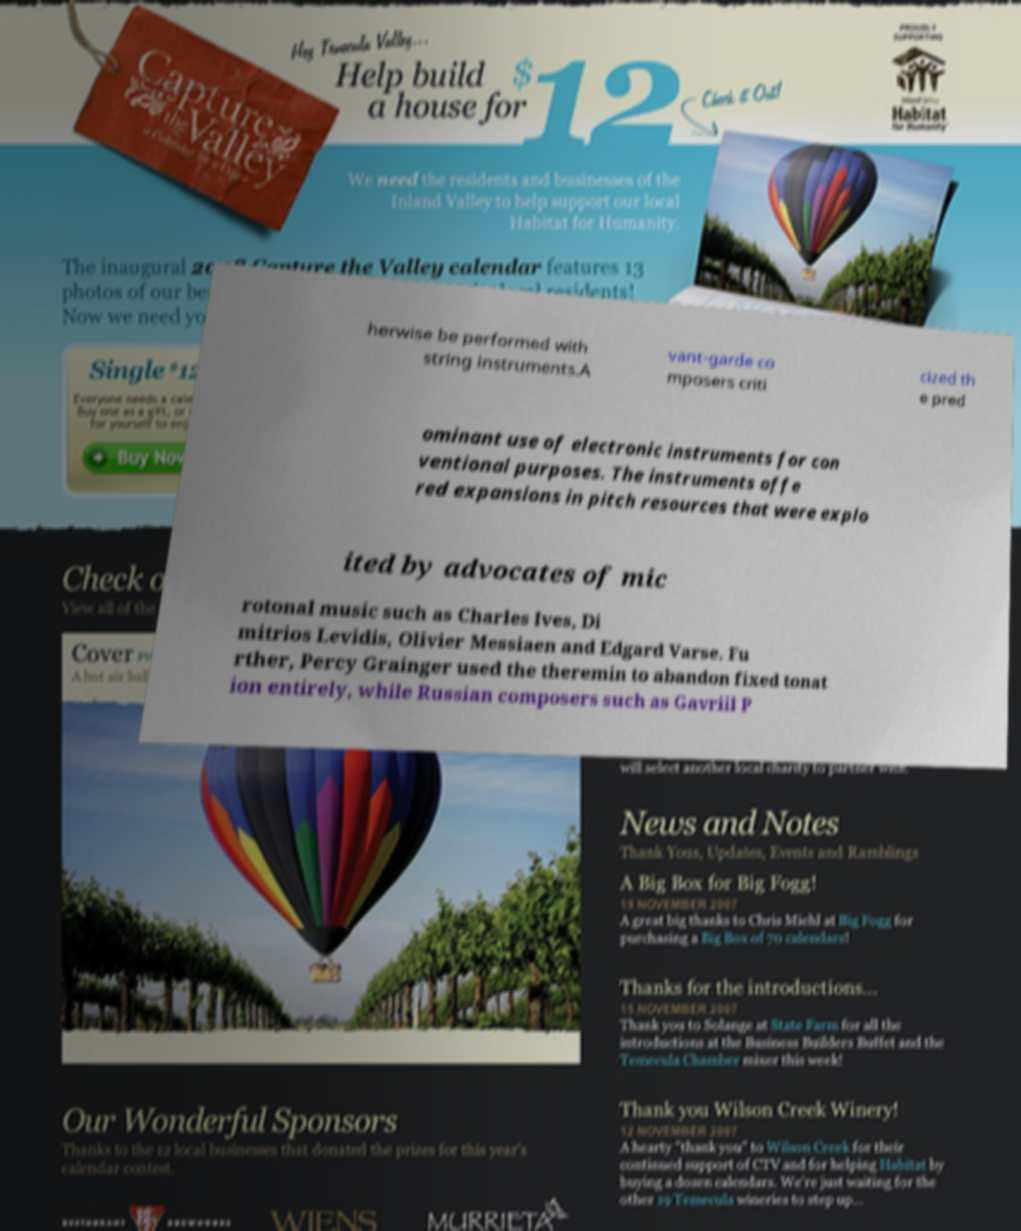I need the written content from this picture converted into text. Can you do that? herwise be performed with string instruments.A vant-garde co mposers criti cized th e pred ominant use of electronic instruments for con ventional purposes. The instruments offe red expansions in pitch resources that were explo ited by advocates of mic rotonal music such as Charles Ives, Di mitrios Levidis, Olivier Messiaen and Edgard Varse. Fu rther, Percy Grainger used the theremin to abandon fixed tonat ion entirely, while Russian composers such as Gavriil P 